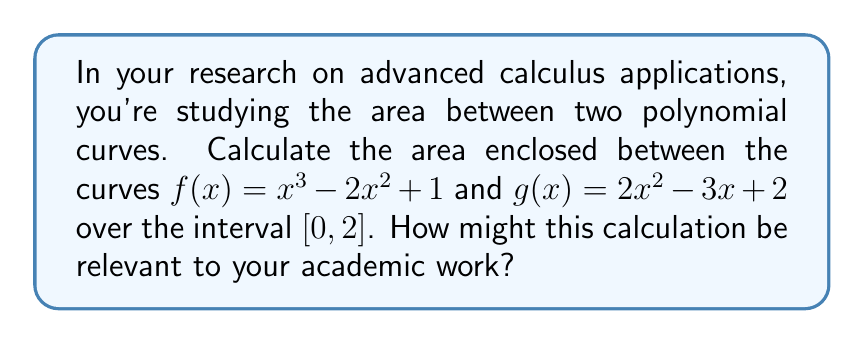Provide a solution to this math problem. To find the area between two polynomial curves, we follow these steps:

1) First, we need to determine which function is "on top" throughout the given interval. We can do this by subtracting $g(x)$ from $f(x)$:

   $f(x) - g(x) = (x^3 - 2x^2 + 1) - (2x^2 - 3x + 2) = x^3 - 4x^2 + 3x - 1$

2) We need to find the roots of this difference in the given interval to see if the functions intersect. We can use a graphing calculator or numerical methods to find that there are no roots in $[0, 2]$. Therefore, one function remains on top throughout the interval.

3) By evaluating $f(0)$ and $g(0)$, we can see that $g(x)$ is on top at $x=0$, so $g(x)$ is the upper function throughout $[0, 2]$.

4) The area between the curves is given by the definite integral of the difference between the upper and lower functions:

   $$A = \int_0^2 [g(x) - f(x)] dx = \int_0^2 [(2x^2 - 3x + 2) - (x^3 - 2x^2 + 1)] dx$$

5) Simplify the integrand:
   
   $$A = \int_0^2 [-x^3 + 4x^2 - 3x + 1] dx$$

6) Integrate:
   
   $$A = \left[-\frac{1}{4}x^4 + \frac{4}{3}x^3 - \frac{3}{2}x^2 + x\right]_0^2$$

7) Evaluate the definite integral:
   
   $$A = \left(-\frac{1}{4}(2^4) + \frac{4}{3}(2^3) - \frac{3}{2}(2^2) + 2\right) - \left(-\frac{1}{4}(0^4) + \frac{4}{3}(0^3) - \frac{3}{2}(0^2) + 0\right)$$
   
   $$A = (-4 + \frac{32}{3} - 6 + 2) - 0 = \frac{14}{3} - 8 = \frac{-10}{3}$$

The negative result indicates that our initial assumption about which function was on top was incorrect. We need to take the absolute value of this result.

This calculation could be relevant to academic research in various ways, such as modeling physical phenomena, analyzing data distributions, or studying geometric properties in higher dimensions.
Answer: The area between the curves $f(x) = x^3 - 2x^2 + 1$ and $g(x) = 2x^2 - 3x + 2$ over the interval $[0, 2]$ is $\frac{10}{3}$ square units. 